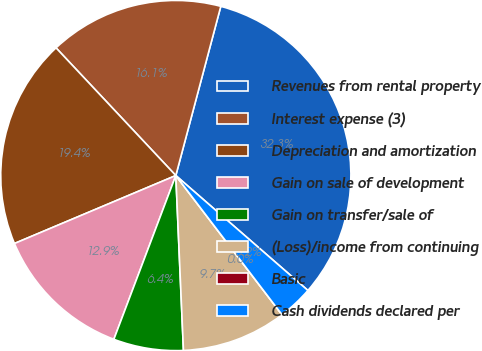Convert chart to OTSL. <chart><loc_0><loc_0><loc_500><loc_500><pie_chart><fcel>Revenues from rental property<fcel>Interest expense (3)<fcel>Depreciation and amortization<fcel>Gain on sale of development<fcel>Gain on transfer/sale of<fcel>(Loss)/income from continuing<fcel>Basic<fcel>Cash dividends declared per<nl><fcel>32.26%<fcel>16.13%<fcel>19.35%<fcel>12.9%<fcel>6.45%<fcel>9.68%<fcel>0.0%<fcel>3.23%<nl></chart> 